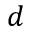Convert formula to latex. <formula><loc_0><loc_0><loc_500><loc_500>d</formula> 